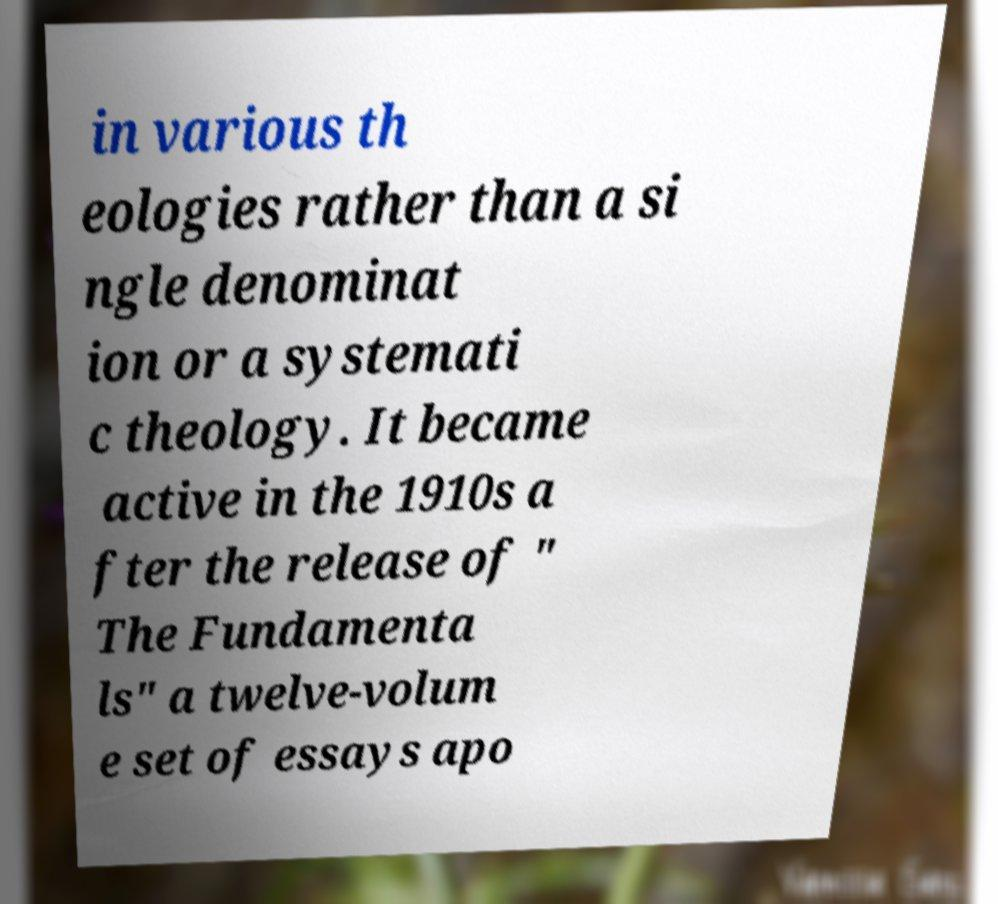Could you assist in decoding the text presented in this image and type it out clearly? in various th eologies rather than a si ngle denominat ion or a systemati c theology. It became active in the 1910s a fter the release of " The Fundamenta ls" a twelve-volum e set of essays apo 